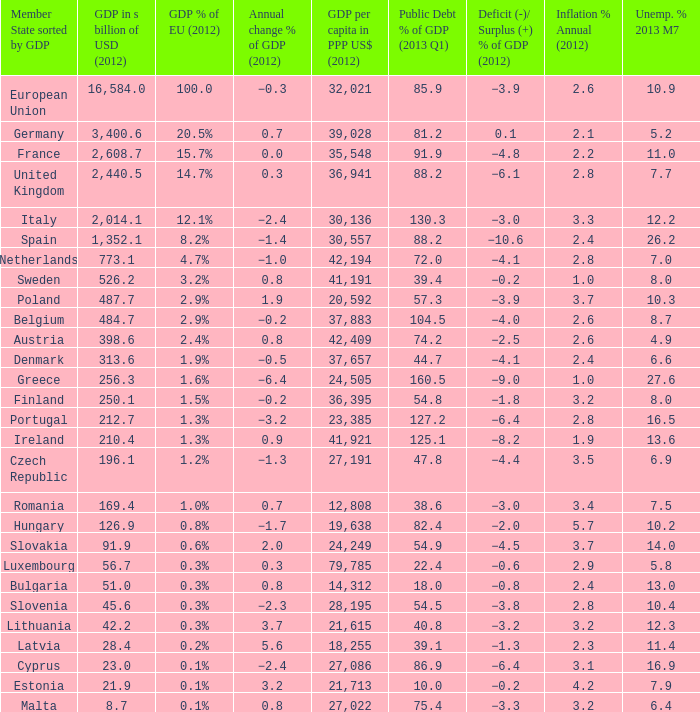What is the GDP % of EU in 2012 of the country with a GDP in billions of USD in 2012 of 256.3? 1.6%. 